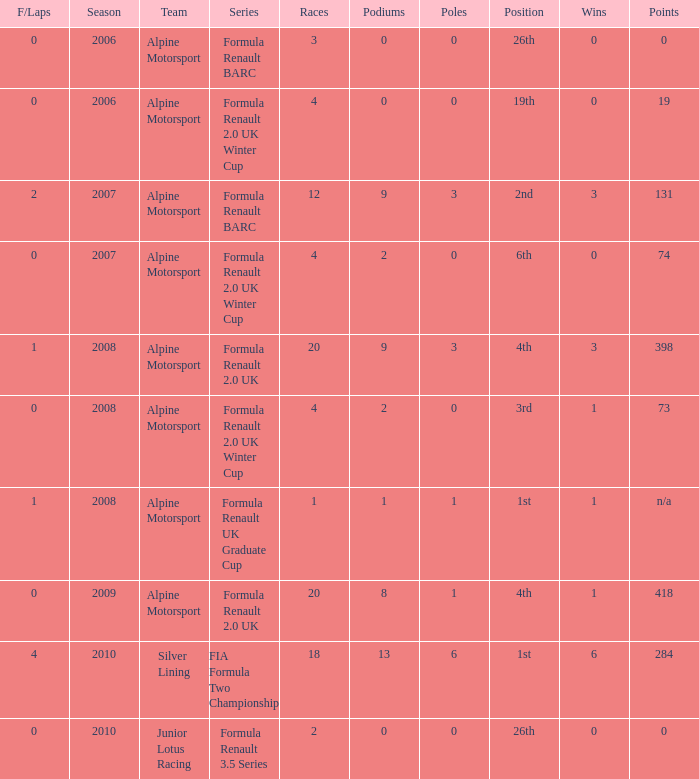How much were the f/laps if poles is higher than 1.0 during 2008? 1.0. Help me parse the entirety of this table. {'header': ['F/Laps', 'Season', 'Team', 'Series', 'Races', 'Podiums', 'Poles', 'Position', 'Wins', 'Points'], 'rows': [['0', '2006', 'Alpine Motorsport', 'Formula Renault BARC', '3', '0', '0', '26th', '0', '0'], ['0', '2006', 'Alpine Motorsport', 'Formula Renault 2.0 UK Winter Cup', '4', '0', '0', '19th', '0', '19'], ['2', '2007', 'Alpine Motorsport', 'Formula Renault BARC', '12', '9', '3', '2nd', '3', '131'], ['0', '2007', 'Alpine Motorsport', 'Formula Renault 2.0 UK Winter Cup', '4', '2', '0', '6th', '0', '74'], ['1', '2008', 'Alpine Motorsport', 'Formula Renault 2.0 UK', '20', '9', '3', '4th', '3', '398'], ['0', '2008', 'Alpine Motorsport', 'Formula Renault 2.0 UK Winter Cup', '4', '2', '0', '3rd', '1', '73'], ['1', '2008', 'Alpine Motorsport', 'Formula Renault UK Graduate Cup', '1', '1', '1', '1st', '1', 'n/a'], ['0', '2009', 'Alpine Motorsport', 'Formula Renault 2.0 UK', '20', '8', '1', '4th', '1', '418'], ['4', '2010', 'Silver Lining', 'FIA Formula Two Championship', '18', '13', '6', '1st', '6', '284'], ['0', '2010', 'Junior Lotus Racing', 'Formula Renault 3.5 Series', '2', '0', '0', '26th', '0', '0']]} 